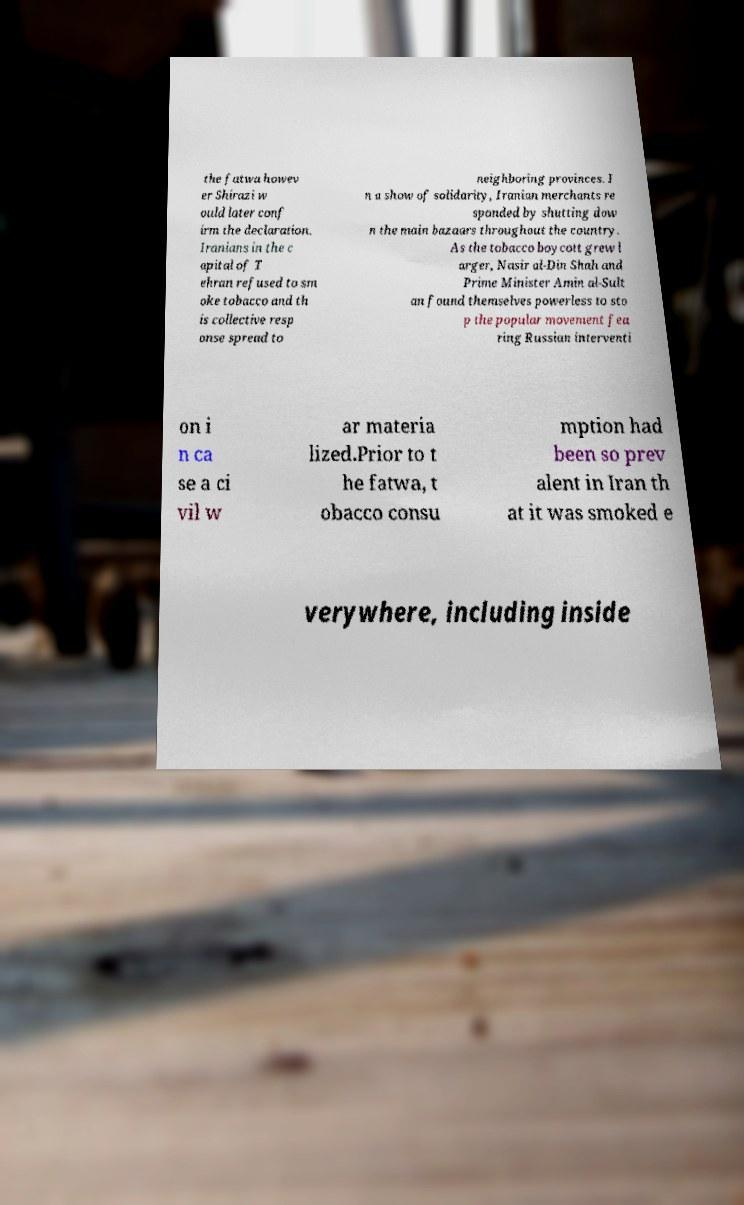Please read and relay the text visible in this image. What does it say? the fatwa howev er Shirazi w ould later conf irm the declaration. Iranians in the c apital of T ehran refused to sm oke tobacco and th is collective resp onse spread to neighboring provinces. I n a show of solidarity, Iranian merchants re sponded by shutting dow n the main bazaars throughout the country. As the tobacco boycott grew l arger, Nasir al-Din Shah and Prime Minister Amin al-Sult an found themselves powerless to sto p the popular movement fea ring Russian interventi on i n ca se a ci vil w ar materia lized.Prior to t he fatwa, t obacco consu mption had been so prev alent in Iran th at it was smoked e verywhere, including inside 